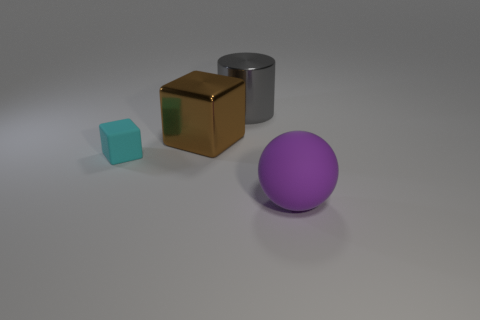Does the gray thing have the same shape as the cyan object?
Provide a short and direct response. No. Is there anything else that is the same material as the big purple ball?
Keep it short and to the point. Yes. What size is the purple object?
Your answer should be very brief. Large. What is the color of the thing that is to the right of the brown metallic cube and behind the matte block?
Provide a succinct answer. Gray. Are there more small yellow rubber spheres than metal blocks?
Keep it short and to the point. No. How many objects are either tiny cubes or cyan matte things in front of the big brown metallic block?
Your answer should be very brief. 1. Is the purple object the same size as the cyan object?
Your response must be concise. No. There is a large brown thing; are there any large purple matte spheres on the left side of it?
Ensure brevity in your answer.  No. What size is the thing that is both on the right side of the rubber block and in front of the big brown metal object?
Offer a very short reply. Large. What number of things are either big gray metal things or brown metallic objects?
Ensure brevity in your answer.  2. 